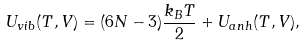Convert formula to latex. <formula><loc_0><loc_0><loc_500><loc_500>U _ { v i b } ( T , V ) = ( 6 N - 3 ) \frac { k _ { B } T } { 2 } + U _ { a n h } ( T , V ) ,</formula> 